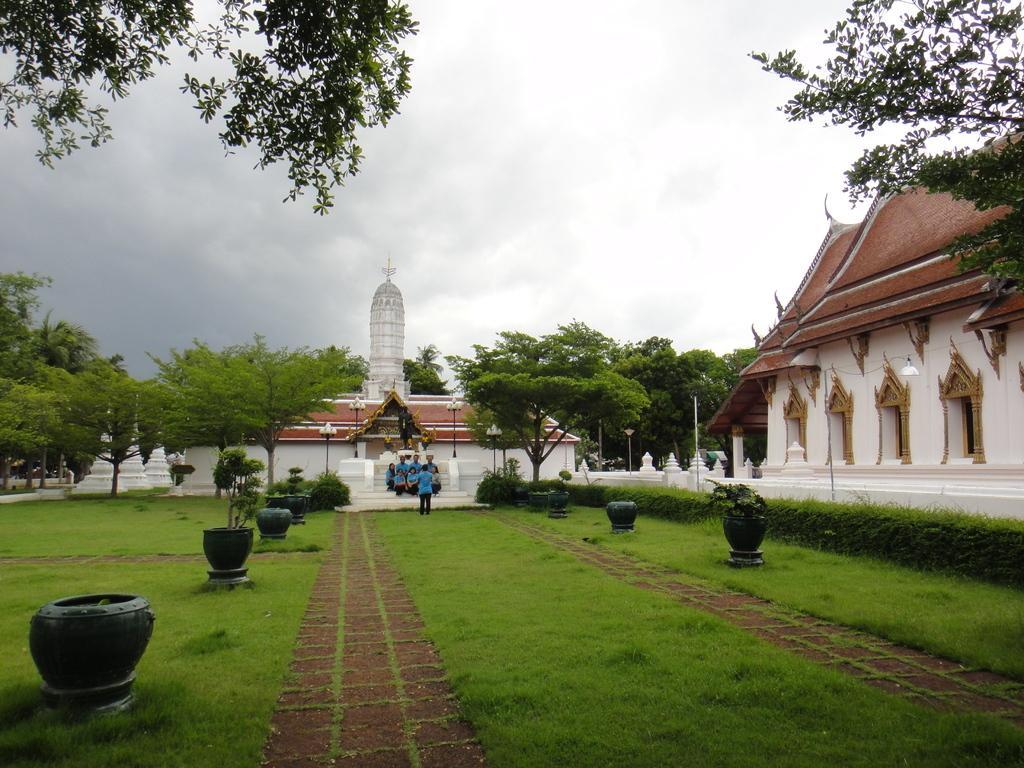Can you describe this image briefly? In this image I can see few persons sitting on the steps. I can see two buildings. There are few trees. I can see few plants and some grass. At the top I can see clouds in the sky. 